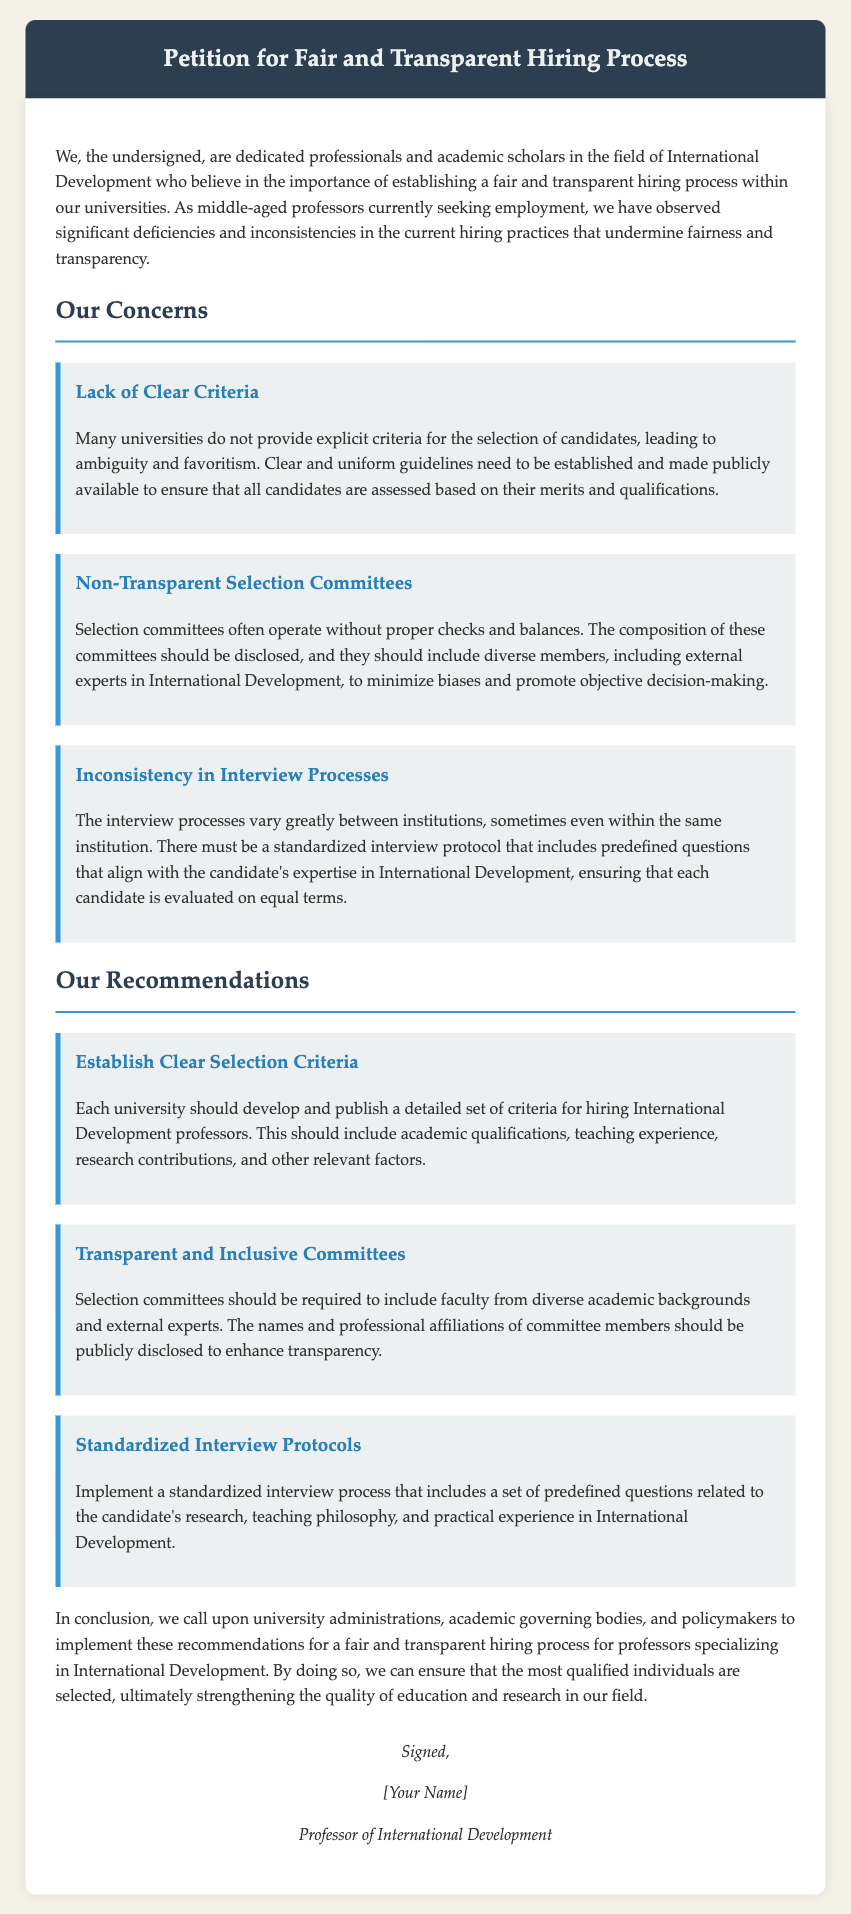What is the main purpose of the petition? The main purpose of the petition is to establish a fair and transparent hiring process for university professors specializing in International Development.
Answer: fair and transparent hiring process Who are the undersigned individuals? The undersigned individuals are dedicated professionals and academic scholars in the field of International Development.
Answer: dedicated professionals and academic scholars What is one significant concern mentioned in the petition? One significant concern mentioned in the petition is the lack of clear criteria for the selection of candidates.
Answer: Lack of Clear Criteria What do the authors recommend regarding selection committees? The authors recommend that selection committees should include faculty from diverse academic backgrounds and external experts.
Answer: include faculty from diverse backgrounds and external experts How many recommendations are presented in the petition? The petition presents a total of three recommendations.
Answer: three What element should be included in standardized interview protocols? Standardized interview protocols should include predefined questions related to the candidate's research.
Answer: predefined questions What is the focus of the candidates the petition is concerned about? The focus is on candidates specializing in International Development.
Answer: International Development What do the authors want university administrations to implement? The authors want university administrations to implement the recommendations for a fair and transparent hiring process.
Answer: recommendations for a fair and transparent hiring process 